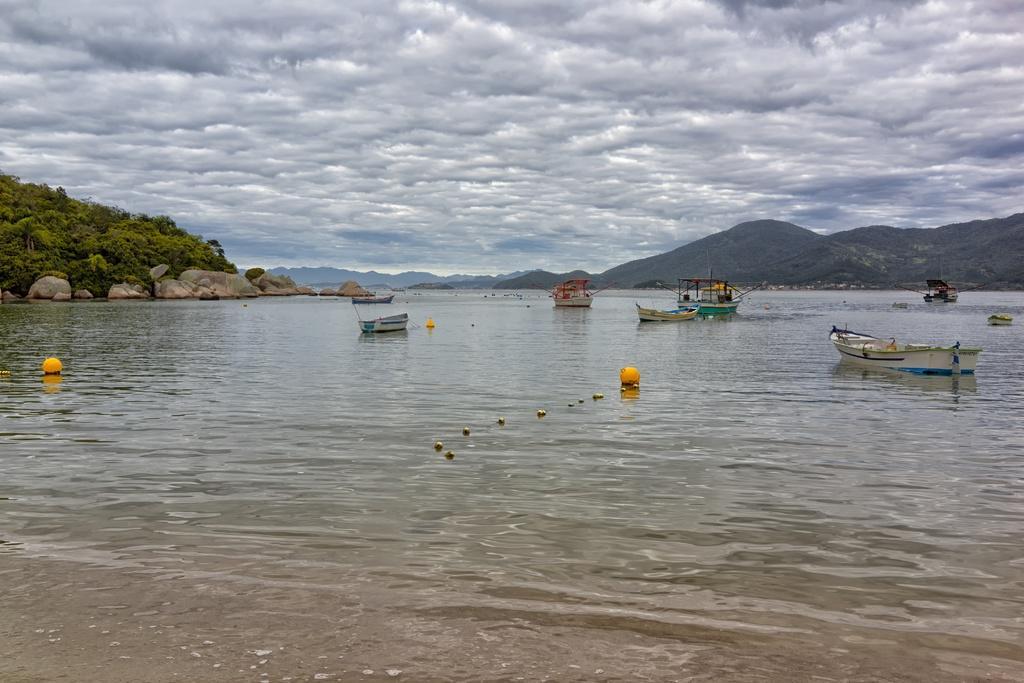Describe this image in one or two sentences. In the picture I can see few boats on the water and there are few rocks and trees in the left corner and there are mountains in the right corner and the sky is cloudy. 